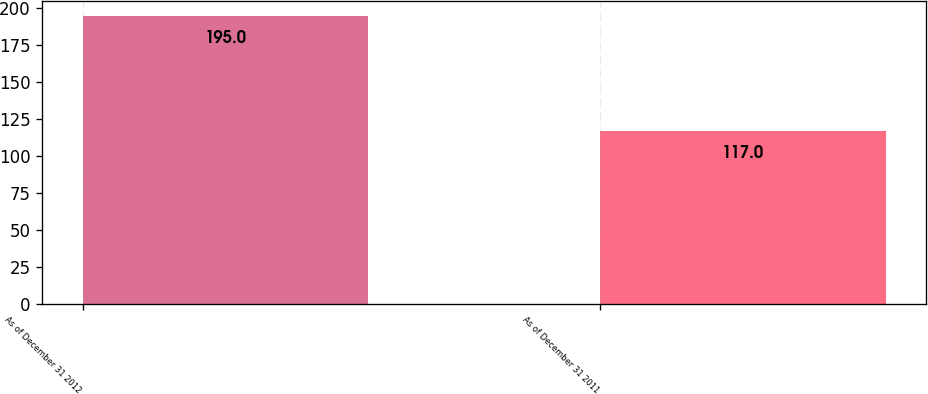Convert chart to OTSL. <chart><loc_0><loc_0><loc_500><loc_500><bar_chart><fcel>As of December 31 2012<fcel>As of December 31 2011<nl><fcel>195<fcel>117<nl></chart> 